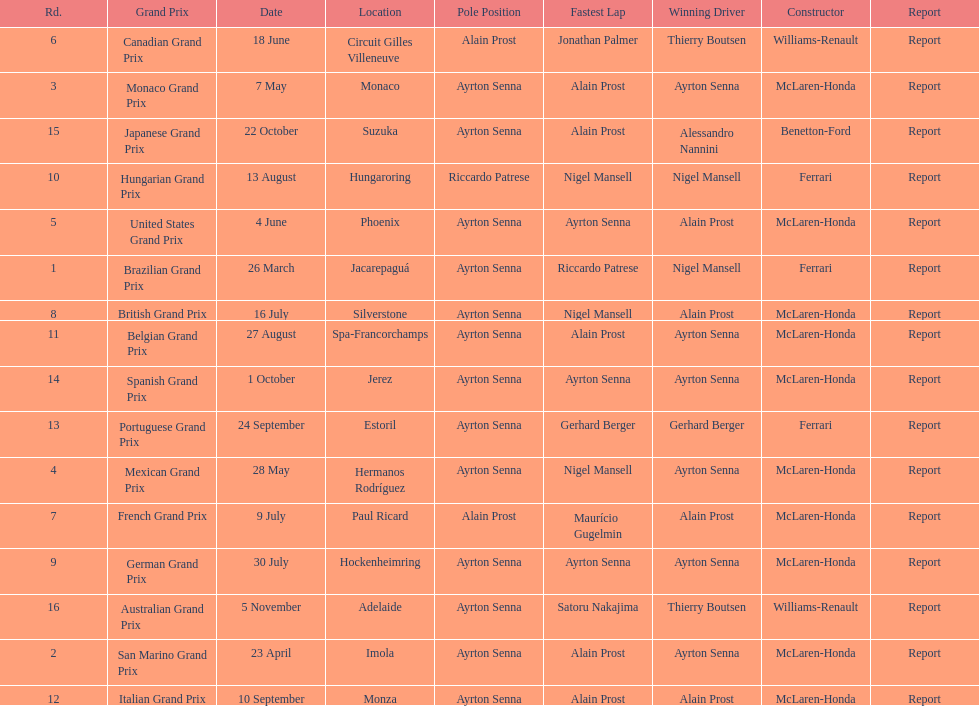How many times was ayrton senna in pole position? 13. 